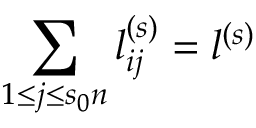<formula> <loc_0><loc_0><loc_500><loc_500>\sum _ { 1 \leq j \leq s _ { 0 } n } l _ { i j } ^ { ( s ) } = l ^ { ( s ) }</formula> 